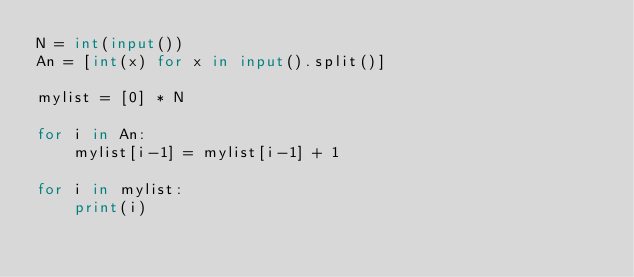<code> <loc_0><loc_0><loc_500><loc_500><_Python_>N = int(input())
An = [int(x) for x in input().split()]

mylist = [0] * N

for i in An:
    mylist[i-1] = mylist[i-1] + 1

for i in mylist:
    print(i)
</code> 